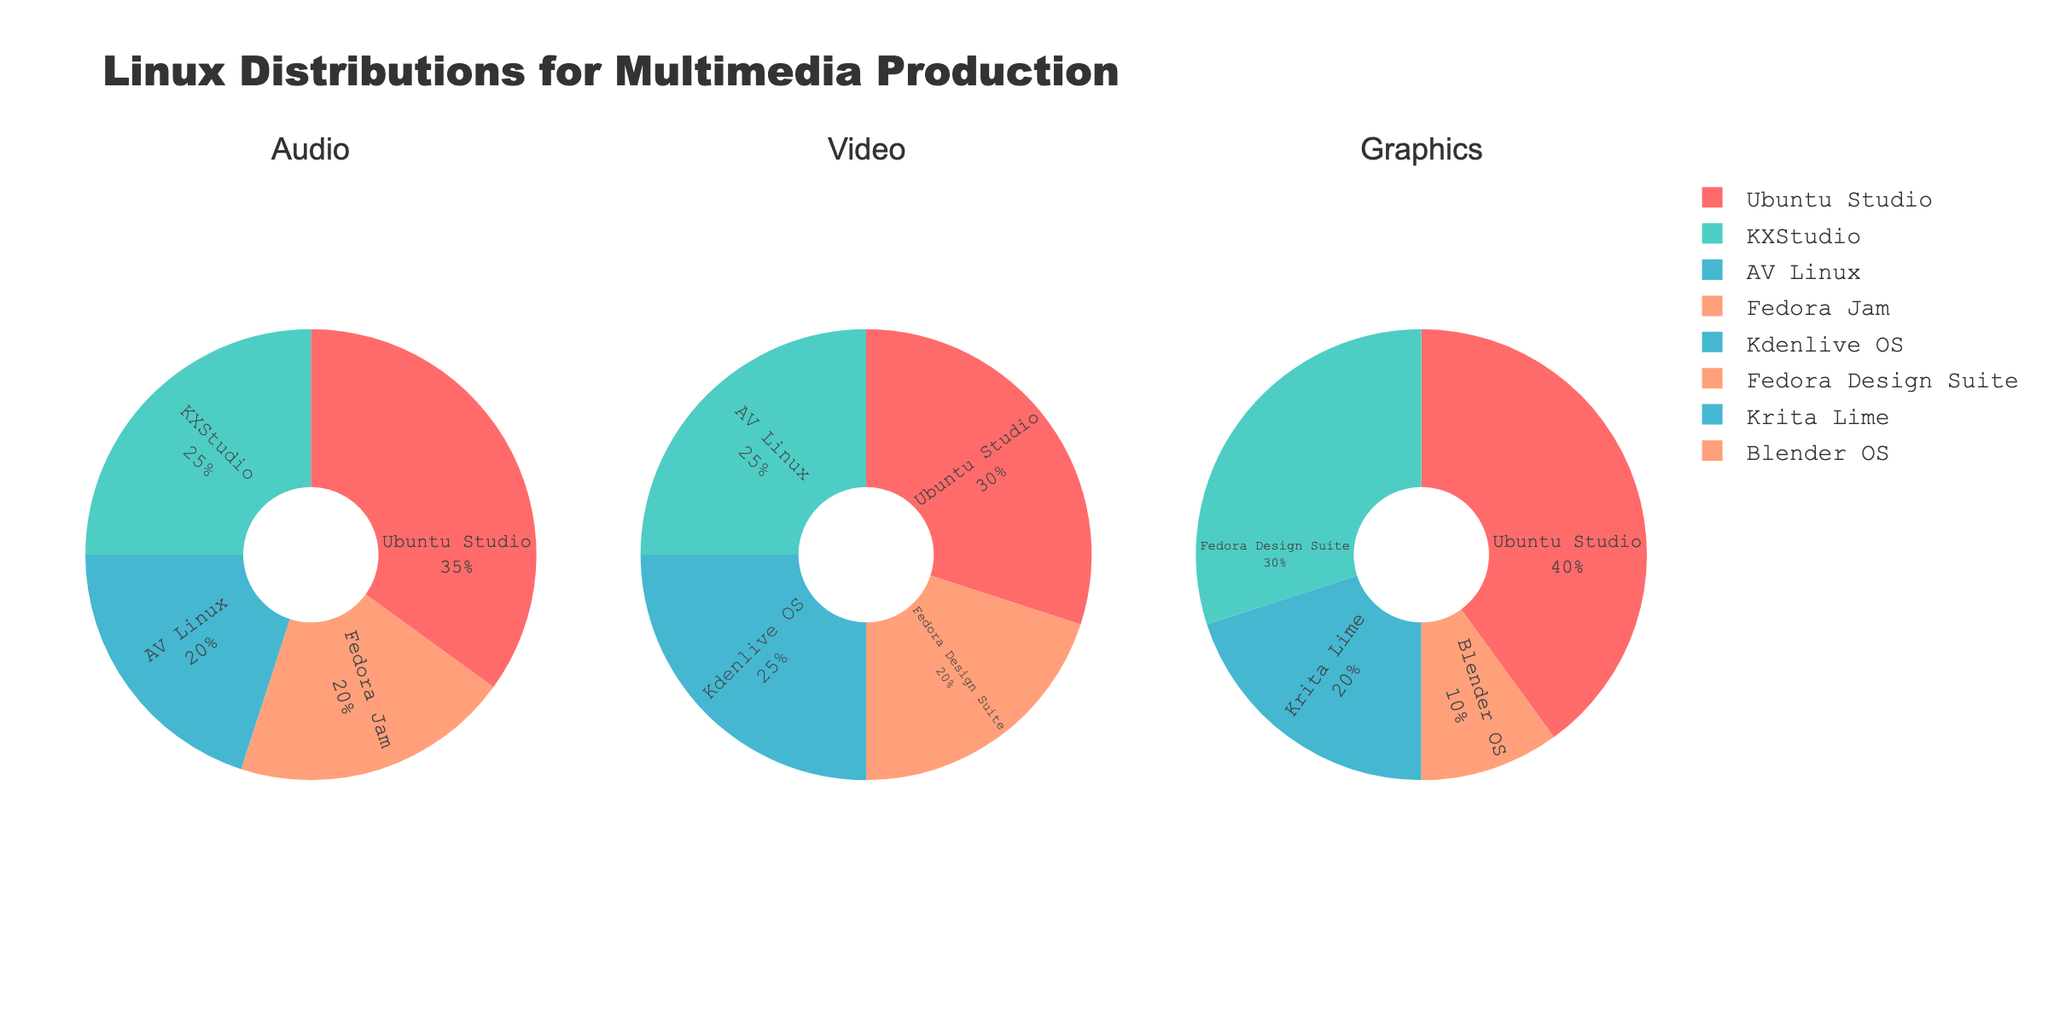Which Linux distribution is most popular for audio production? The pie chart under the "Audio" category shows that Ubuntu Studio covers the largest segment.
Answer: Ubuntu Studio Which Linux distribution is least popular for graphics production? The pie chart under the "Graphics" category shows that Blender OS has the smallest segment.
Answer: Blender OS Which Linux distribution has the same percentage share in both audio and video production? Both Audio and Video pie charts show the same 20% share for Fedora variants; Fedora Jam in Audio and Fedora Design Suite in Video.
Answer: Fedora What's the total percentage of all distributions used for video production other than Ubuntu Studio? The percentages of AV Linux (25%), Kdenlive OS (25%), and Fedora Design Suite (20%) are 25 + 25 + 20 = 70.
Answer: 70% Is Ubuntu Studio more popular in graphics or video production? Comparing the segments for Ubuntu Studio in both Graphics (40%) and Video (30%) categories shows it's more popular in Graphics production.
Answer: Graphics Which category has the most balanced distribution among all Linux distributions? The Video chart has segments of 30%, 25%, 25%, and 20%, which are more balanced compared to the other charts.
Answer: Video What's the combined percentage of Fedora Design Suite in both video and graphics categories? Fedora Design Suite has 20% in Video and 30% in Graphics, so 20 + 30 = 50.
Answer: 50% How does the popularity of KXStudio in audio compare to its popularity in video? KXStudio is represented in 25% of the Audio segment and has no share in the Video category, making it less popular for Video.
Answer: More popular in Audio Which primary focus category does Ubuntu Studio dominate the most? Comparing the Ubuntu Studio segments in Audio (35%), Video (30%), and Graphics (40%) shows it dominates the Graphics category the most.
Answer: Graphics 